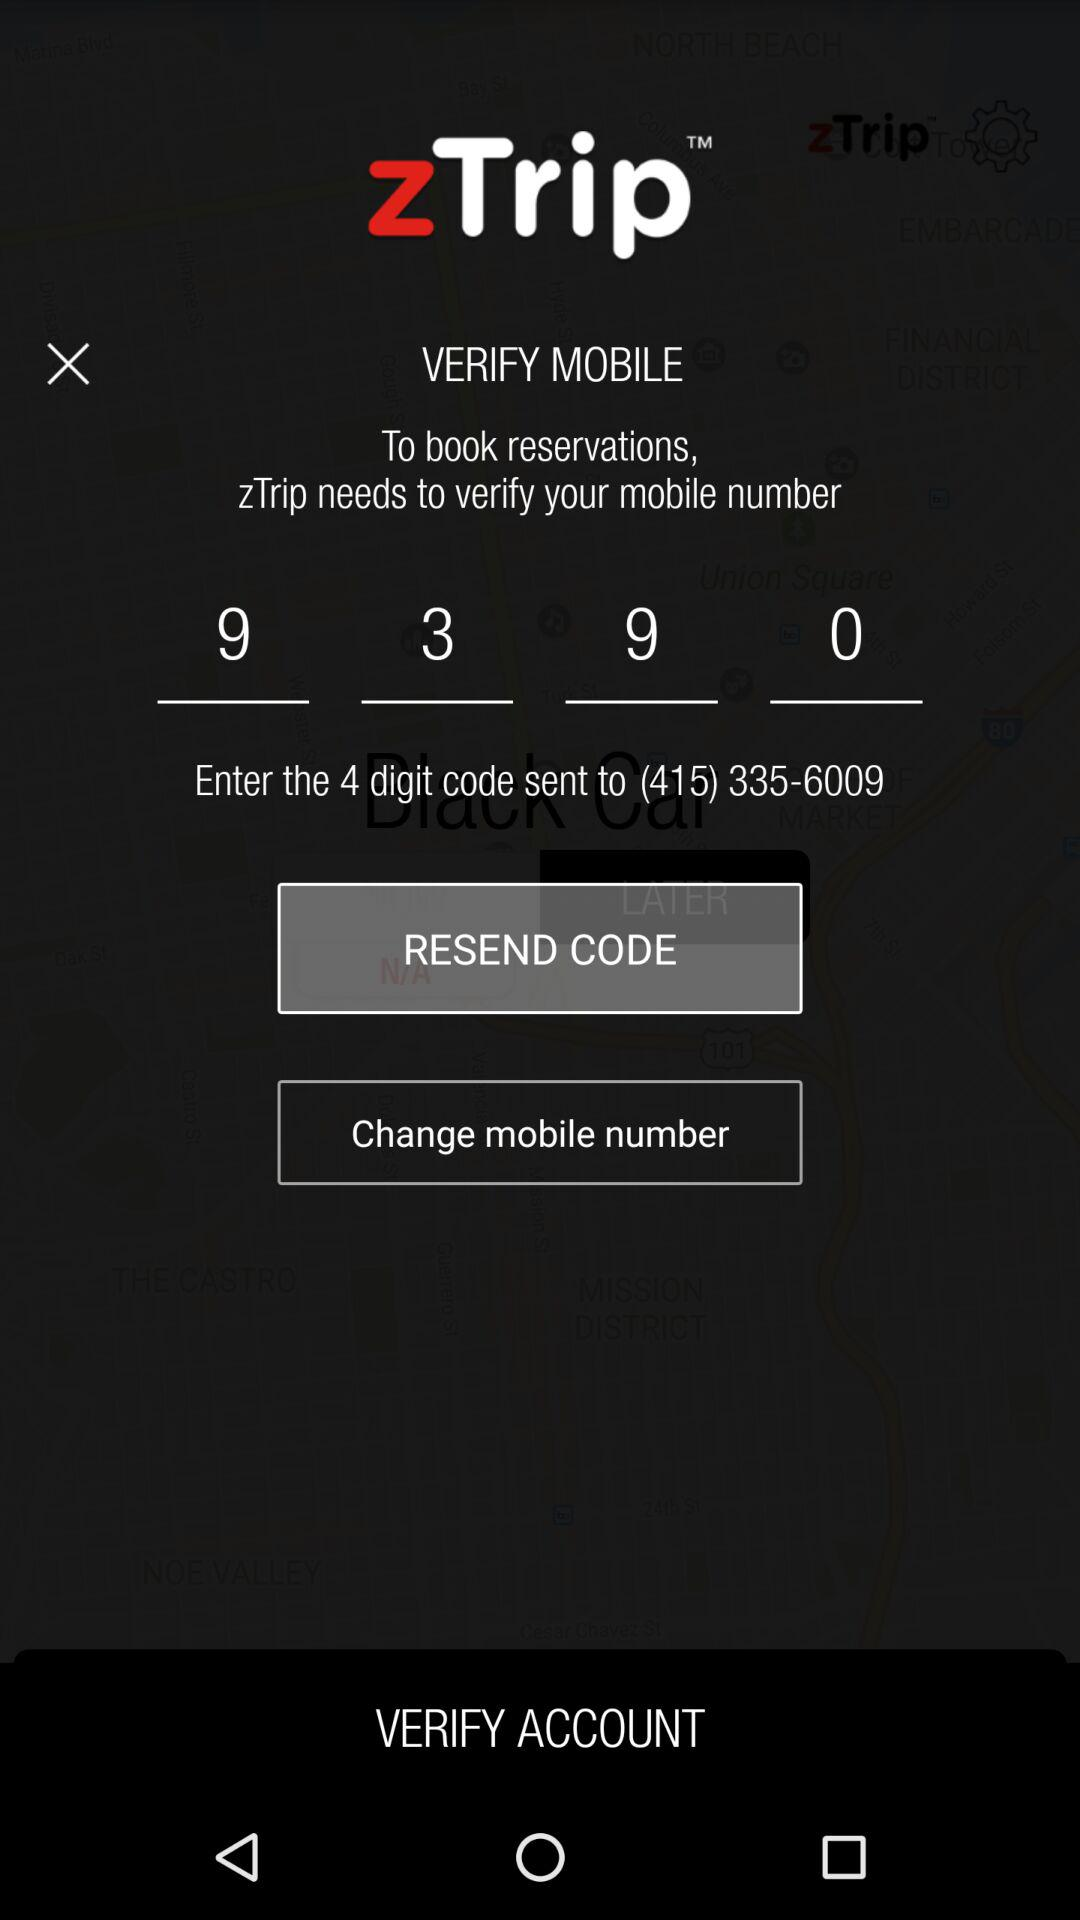What is the four-digit code? The four-digit code is 9390. 